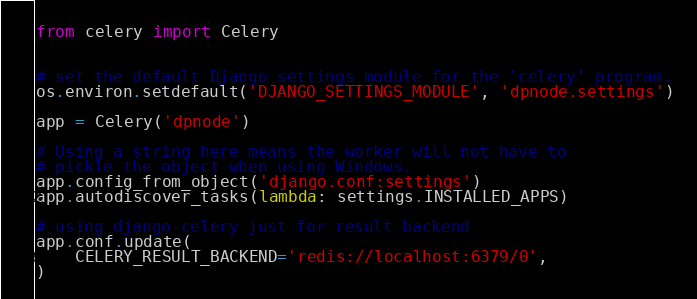<code> <loc_0><loc_0><loc_500><loc_500><_Python_>
from celery import Celery


# set the default Django settings module for the 'celery' program.
os.environ.setdefault('DJANGO_SETTINGS_MODULE', 'dpnode.settings')

app = Celery('dpnode')

# Using a string here means the worker will not have to
# pickle the object when using Windows.
app.config_from_object('django.conf:settings')
app.autodiscover_tasks(lambda: settings.INSTALLED_APPS)

# using django-celery just for result backend
app.conf.update(
    CELERY_RESULT_BACKEND='redis://localhost:6379/0',
)</code> 